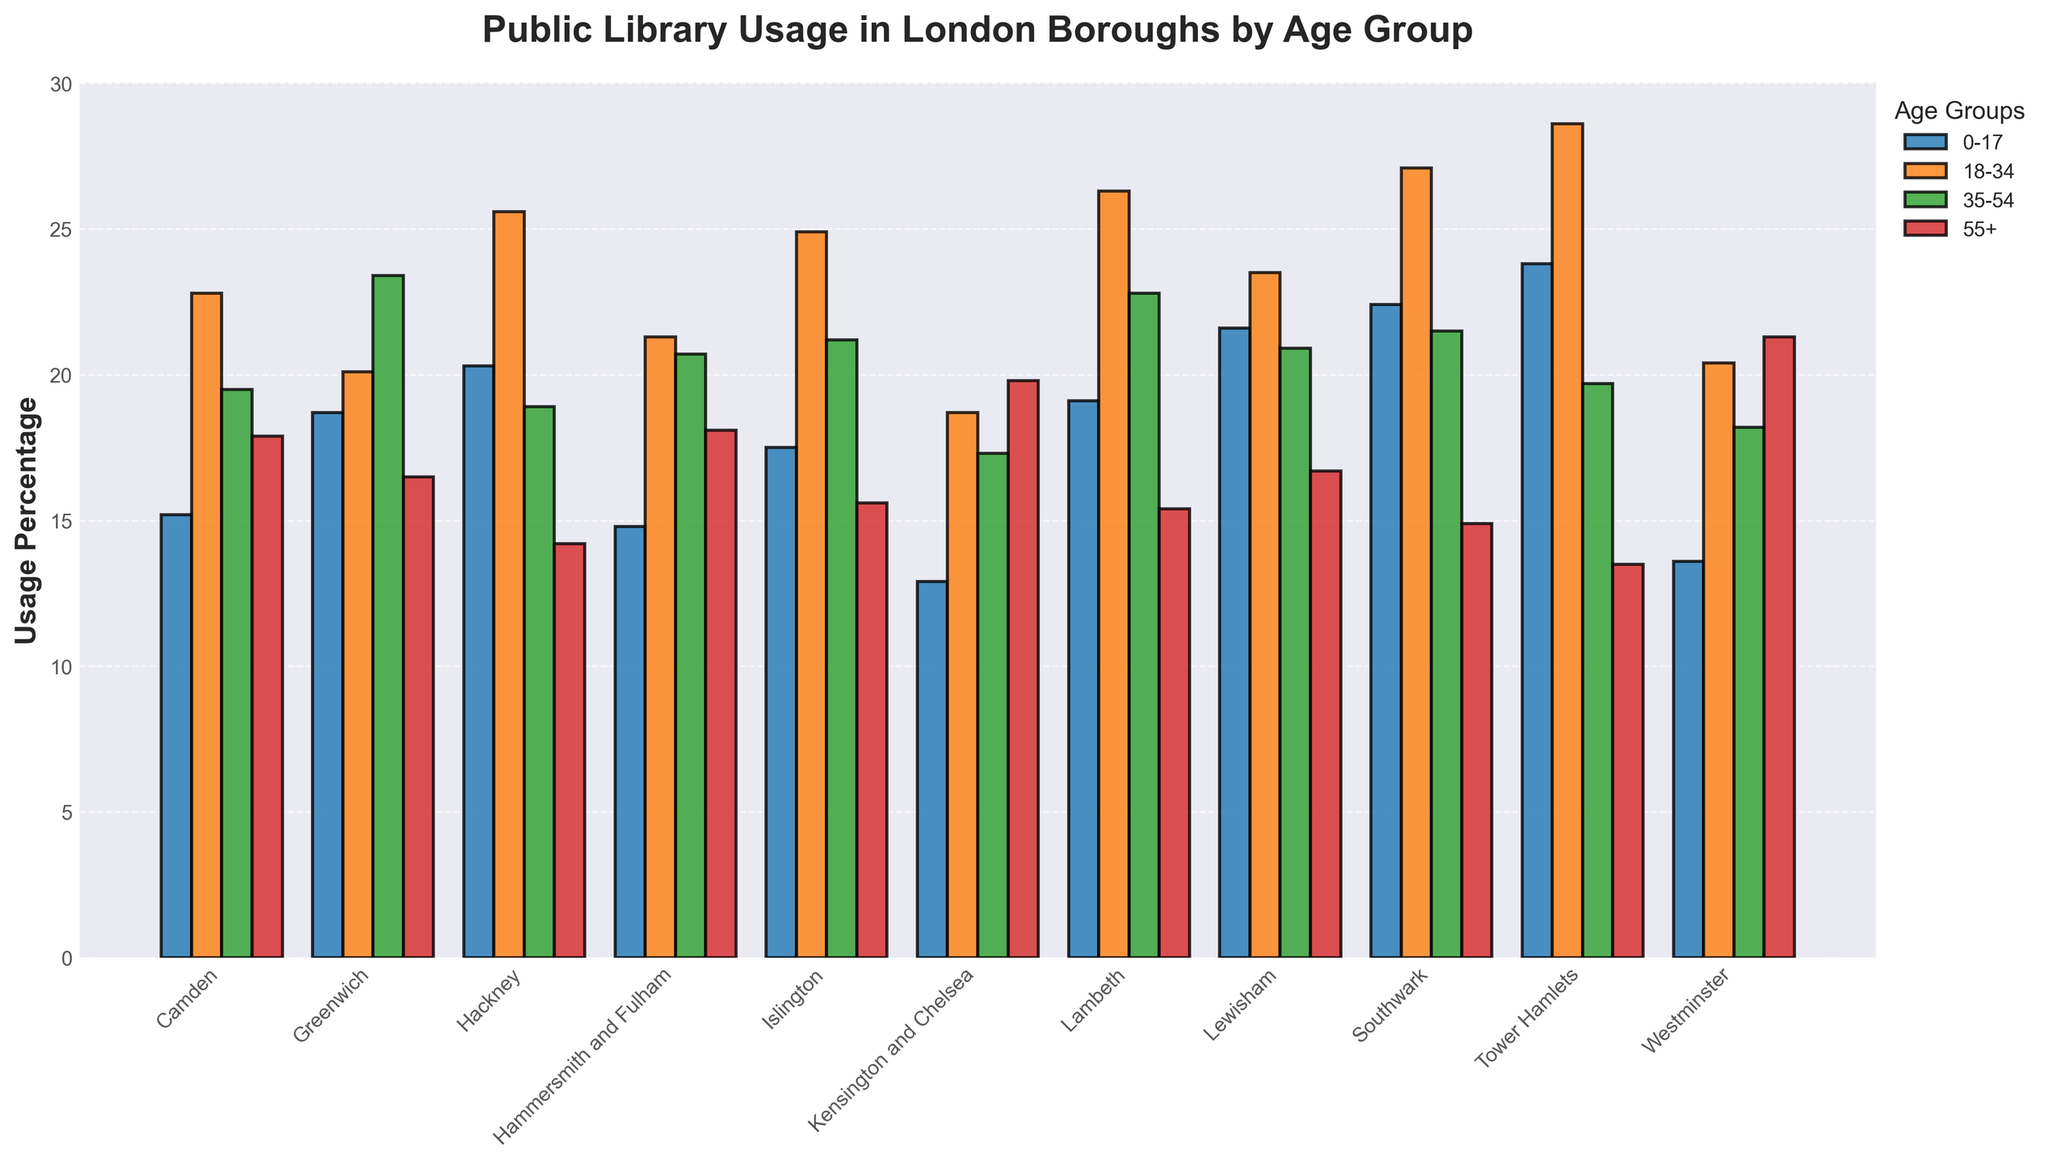Which borough has the highest public library usage for the age group 18-34? By looking at the height of the bars for the age group 18-34 across all boroughs, the tallest bar indicates the highest usage.
Answer: Tower Hamlets Which age group has the highest average usage across all London boroughs? Calculate the average usage for each age group by summing the usage percentages across all boroughs and dividing by the number of boroughs. The age group with the highest average is the one we seek.
Answer: 18-34 Compare the library usage for the age group 0-17 in Camden and Tower Hamlets. Which borough has higher usage? Compare the heights of the bars corresponding to the age group 0-17 for Camden and Tower Hamlets. The bar that is higher shows the borough with higher usage.
Answer: Tower Hamlets In which borough is the library usage by the age group 55+ higher, Westminster or Kensington and Chelsea? Compare the heights of the bars for the age group 55+ in Westminster and Kensington and Chelsea. The higher bar shows the borough with the higher usage.
Answer: Westminster What is the total library usage of the 55+ age group in Hackney and Islington combined? Add the usage percentages for the 55+ age group in Hackney and Islington.
Answer: 29.8 Which borough has the smallest difference in library usage between age groups 18-34 and 35-54? Calculate the absolute difference in usage percentages for age groups 18-34 and 35-54 in each borough. The borough with the smallest difference is the answer.
Answer: Southwark Identify the borough with the lowest average usage across all age groups. Calculate the average usage for all age groups in each borough. The borough with the lowest average is the one we are looking for.
Answer: Kensington and Chelsea What is the combined library usage percentage for all age groups in lambeth? Sum the library usage percentages across all age groups in Lambeth.
Answer: 83.6 Which age group has the least variation in usage percentages across all boroughs? Determine the range (max - min) of usage percentages for each age group across all boroughs. The age group with the smallest range has the least variation.
Answer: 0-17 In which borough is the disparity between the youngest (0-17) and the oldest (55+) age groups' library usage the greatest? Calculate the absolute difference between the 0-17 and 55+ age group usage percentages for each borough. The borough with the greatest difference is the one you are looking for.
Answer: Tower Hamlets 